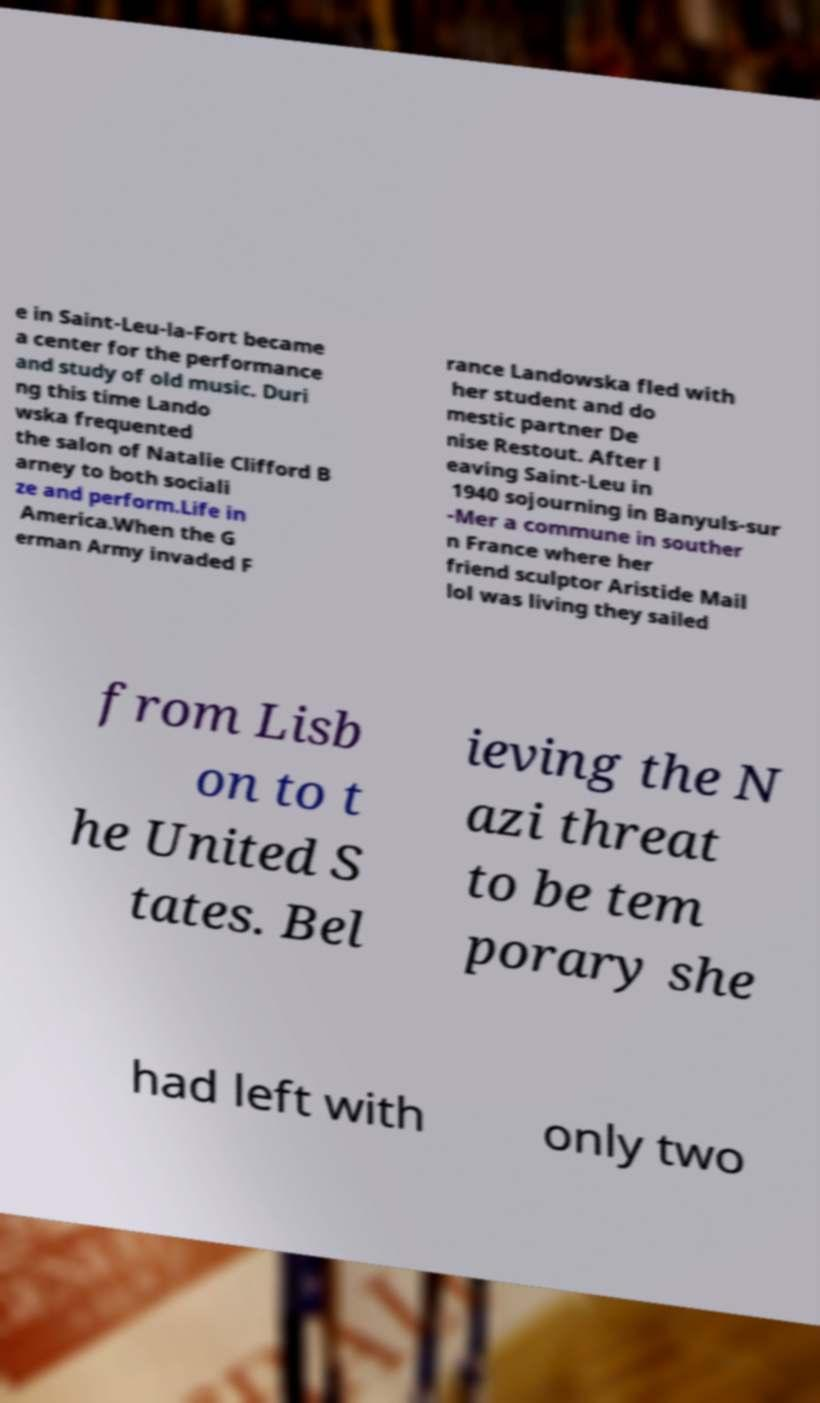What messages or text are displayed in this image? I need them in a readable, typed format. e in Saint-Leu-la-Fort became a center for the performance and study of old music. Duri ng this time Lando wska frequented the salon of Natalie Clifford B arney to both sociali ze and perform.Life in America.When the G erman Army invaded F rance Landowska fled with her student and do mestic partner De nise Restout. After l eaving Saint-Leu in 1940 sojourning in Banyuls-sur -Mer a commune in souther n France where her friend sculptor Aristide Mail lol was living they sailed from Lisb on to t he United S tates. Bel ieving the N azi threat to be tem porary she had left with only two 